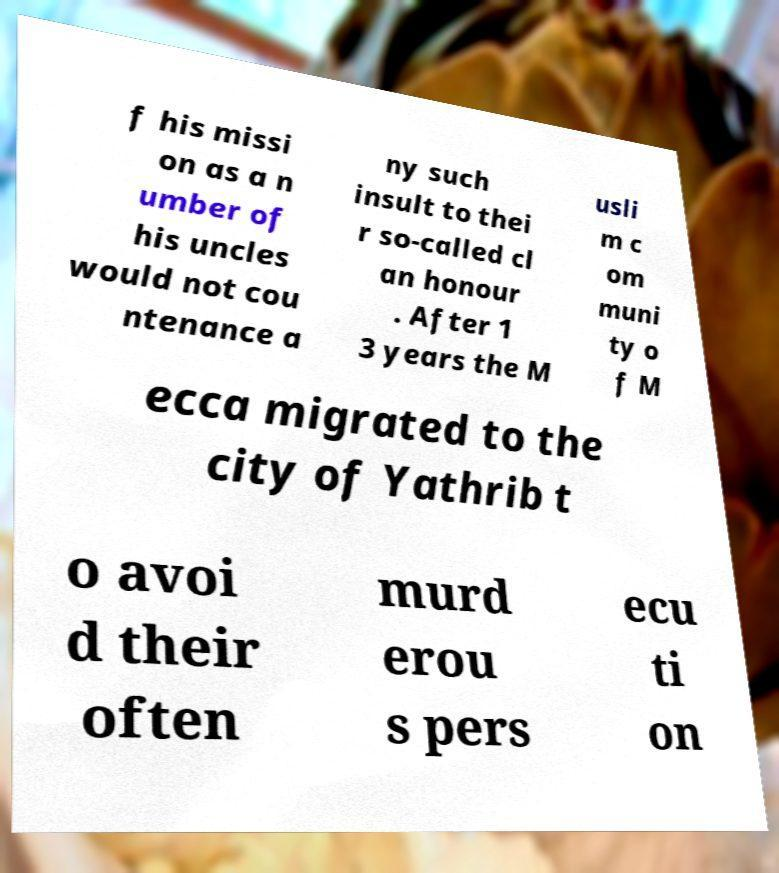Can you accurately transcribe the text from the provided image for me? f his missi on as a n umber of his uncles would not cou ntenance a ny such insult to thei r so-called cl an honour . After 1 3 years the M usli m c om muni ty o f M ecca migrated to the city of Yathrib t o avoi d their often murd erou s pers ecu ti on 